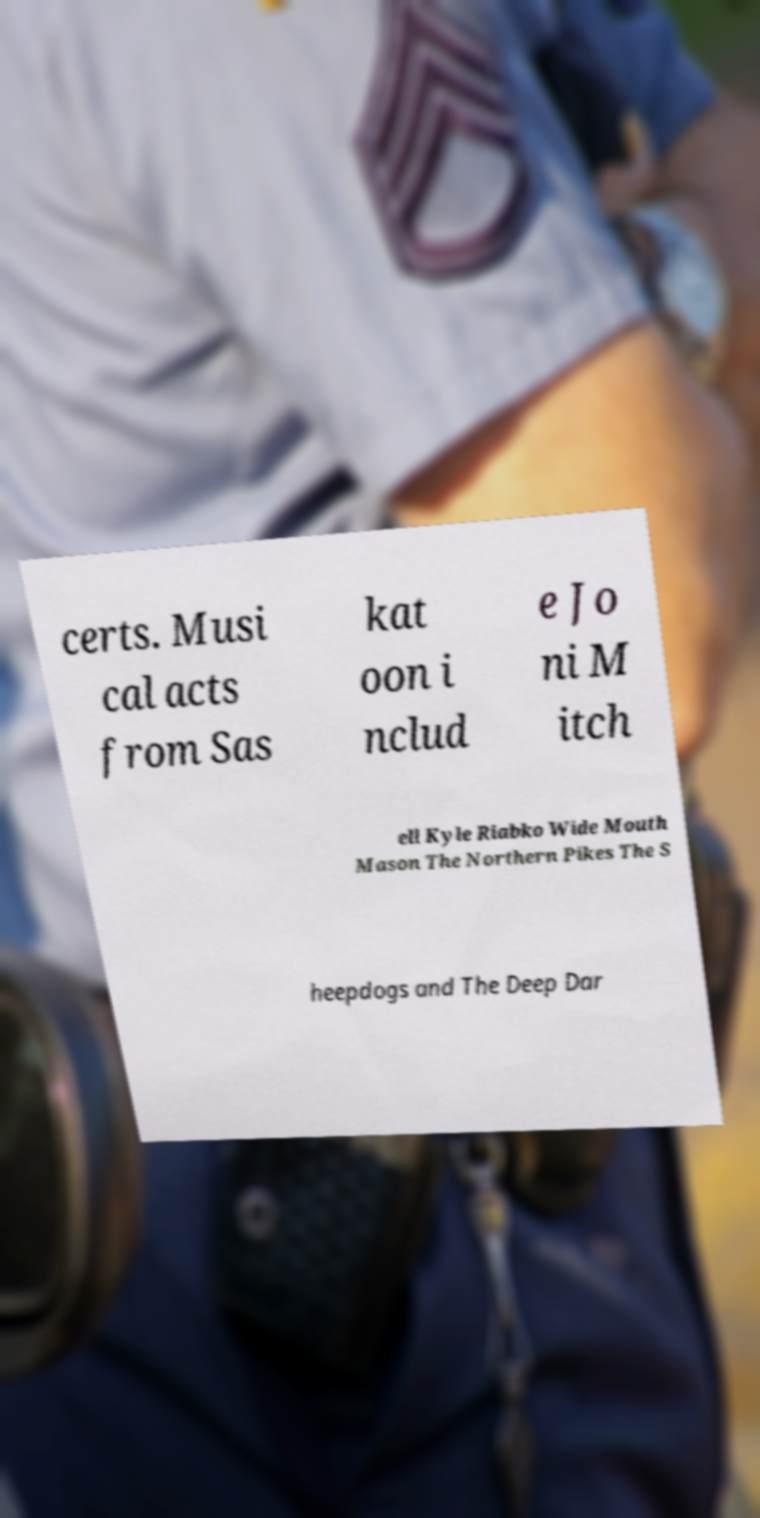I need the written content from this picture converted into text. Can you do that? certs. Musi cal acts from Sas kat oon i nclud e Jo ni M itch ell Kyle Riabko Wide Mouth Mason The Northern Pikes The S heepdogs and The Deep Dar 